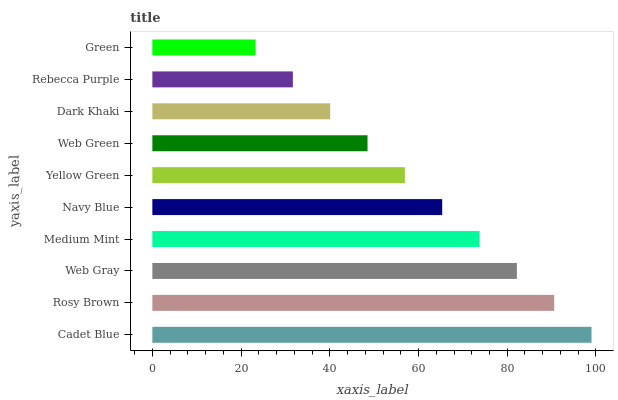Is Green the minimum?
Answer yes or no. Yes. Is Cadet Blue the maximum?
Answer yes or no. Yes. Is Rosy Brown the minimum?
Answer yes or no. No. Is Rosy Brown the maximum?
Answer yes or no. No. Is Cadet Blue greater than Rosy Brown?
Answer yes or no. Yes. Is Rosy Brown less than Cadet Blue?
Answer yes or no. Yes. Is Rosy Brown greater than Cadet Blue?
Answer yes or no. No. Is Cadet Blue less than Rosy Brown?
Answer yes or no. No. Is Navy Blue the high median?
Answer yes or no. Yes. Is Yellow Green the low median?
Answer yes or no. Yes. Is Rebecca Purple the high median?
Answer yes or no. No. Is Cadet Blue the low median?
Answer yes or no. No. 